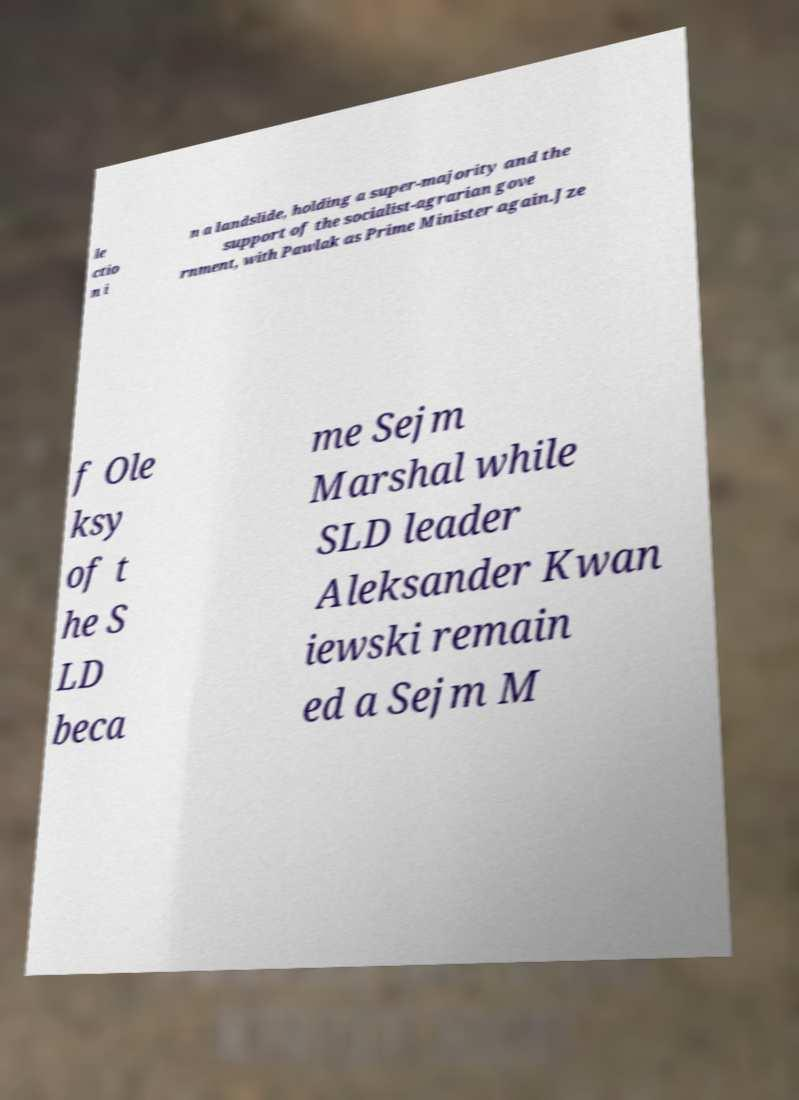Can you accurately transcribe the text from the provided image for me? le ctio n i n a landslide, holding a super-majority and the support of the socialist-agrarian gove rnment, with Pawlak as Prime Minister again.Jze f Ole ksy of t he S LD beca me Sejm Marshal while SLD leader Aleksander Kwan iewski remain ed a Sejm M 